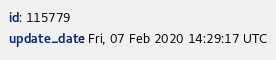<code> <loc_0><loc_0><loc_500><loc_500><_YAML_>id: 115779
update_date: Fri, 07 Feb 2020 14:29:17 UTC
</code> 